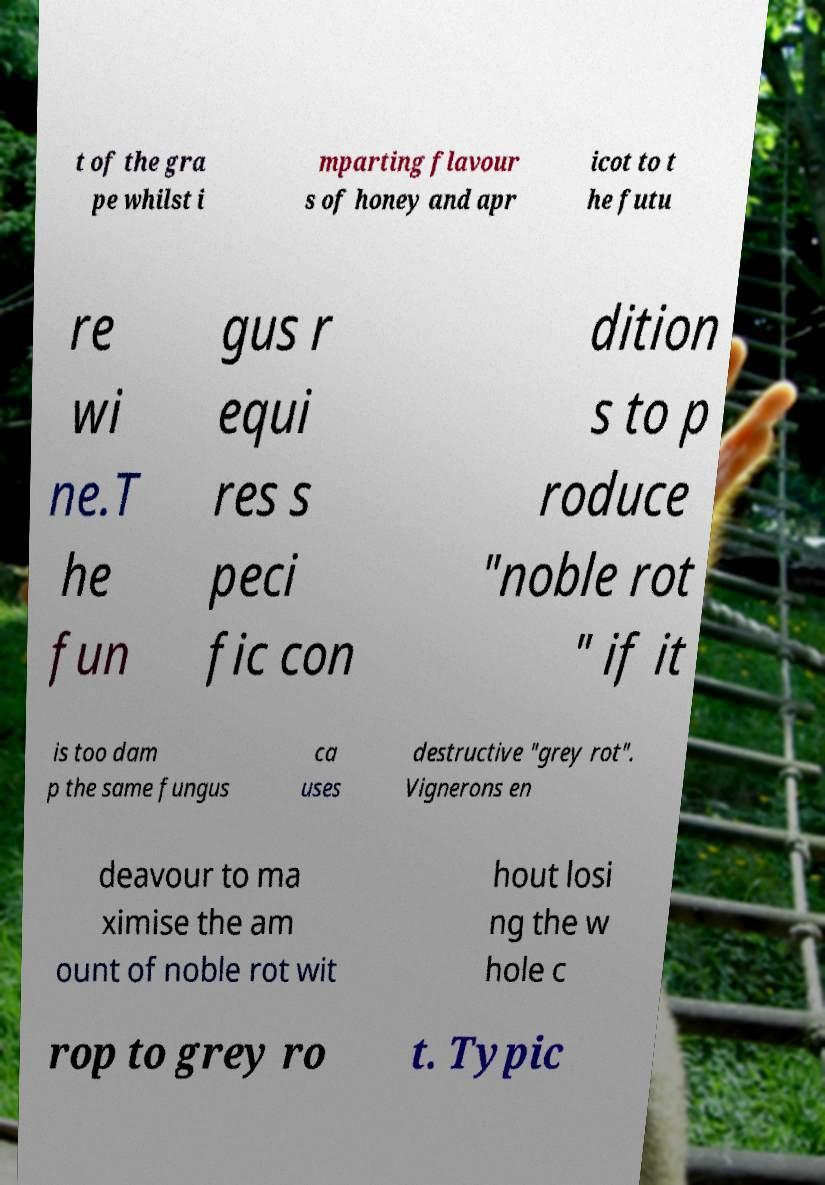Please identify and transcribe the text found in this image. t of the gra pe whilst i mparting flavour s of honey and apr icot to t he futu re wi ne.T he fun gus r equi res s peci fic con dition s to p roduce "noble rot " if it is too dam p the same fungus ca uses destructive "grey rot". Vignerons en deavour to ma ximise the am ount of noble rot wit hout losi ng the w hole c rop to grey ro t. Typic 